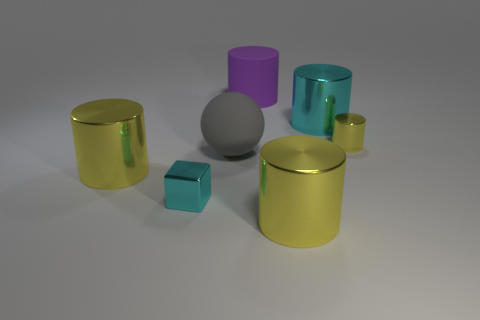There is a purple cylinder; what number of tiny shiny objects are in front of it?
Offer a terse response. 2. What is the size of the shiny block?
Your answer should be very brief. Small. What color is the tiny cylinder that is the same material as the cyan block?
Make the answer very short. Yellow. How many matte cylinders are the same size as the cube?
Your response must be concise. 0. Does the small thing right of the large cyan metal cylinder have the same material as the gray ball?
Your answer should be very brief. No. Are there fewer large gray spheres that are behind the small cyan block than small blue things?
Keep it short and to the point. No. The rubber object in front of the matte cylinder has what shape?
Your response must be concise. Sphere. What is the shape of the cyan object that is the same size as the purple cylinder?
Make the answer very short. Cylinder. Are there any yellow things that have the same shape as the big purple thing?
Give a very brief answer. Yes. There is a big matte object behind the small yellow metallic cylinder; does it have the same shape as the gray thing that is in front of the rubber cylinder?
Offer a terse response. No. 